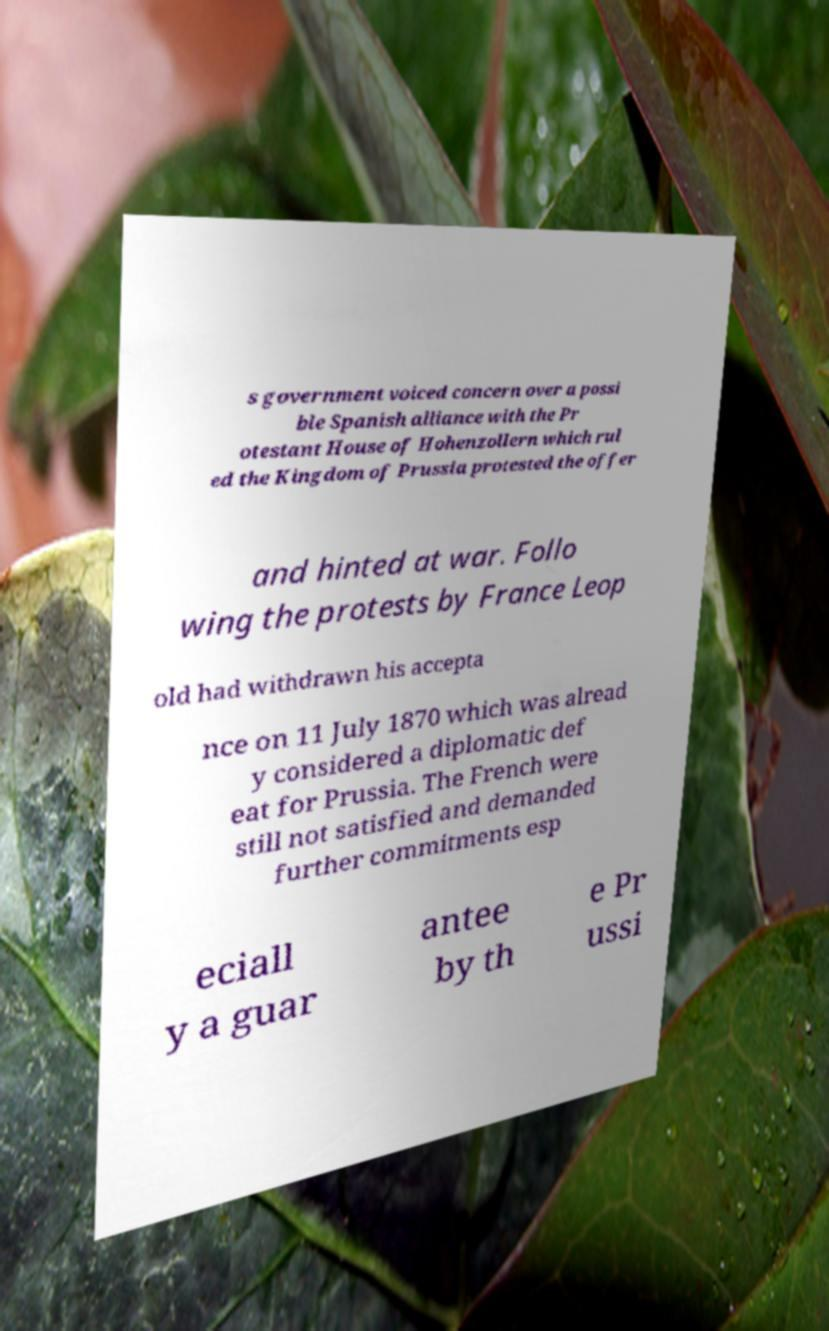Could you assist in decoding the text presented in this image and type it out clearly? s government voiced concern over a possi ble Spanish alliance with the Pr otestant House of Hohenzollern which rul ed the Kingdom of Prussia protested the offer and hinted at war. Follo wing the protests by France Leop old had withdrawn his accepta nce on 11 July 1870 which was alread y considered a diplomatic def eat for Prussia. The French were still not satisfied and demanded further commitments esp eciall y a guar antee by th e Pr ussi 